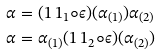Convert formula to latex. <formula><loc_0><loc_0><loc_500><loc_500>\alpha & = ( 1 \, 1 _ { 1 } \circ \epsilon ) ( \alpha _ { ( 1 ) } ) \alpha _ { ( 2 ) } \\ \alpha & = \alpha _ { ( 1 ) } ( 1 \, 1 _ { 2 } \circ \epsilon ) ( \alpha _ { ( 2 ) } ) \\</formula> 